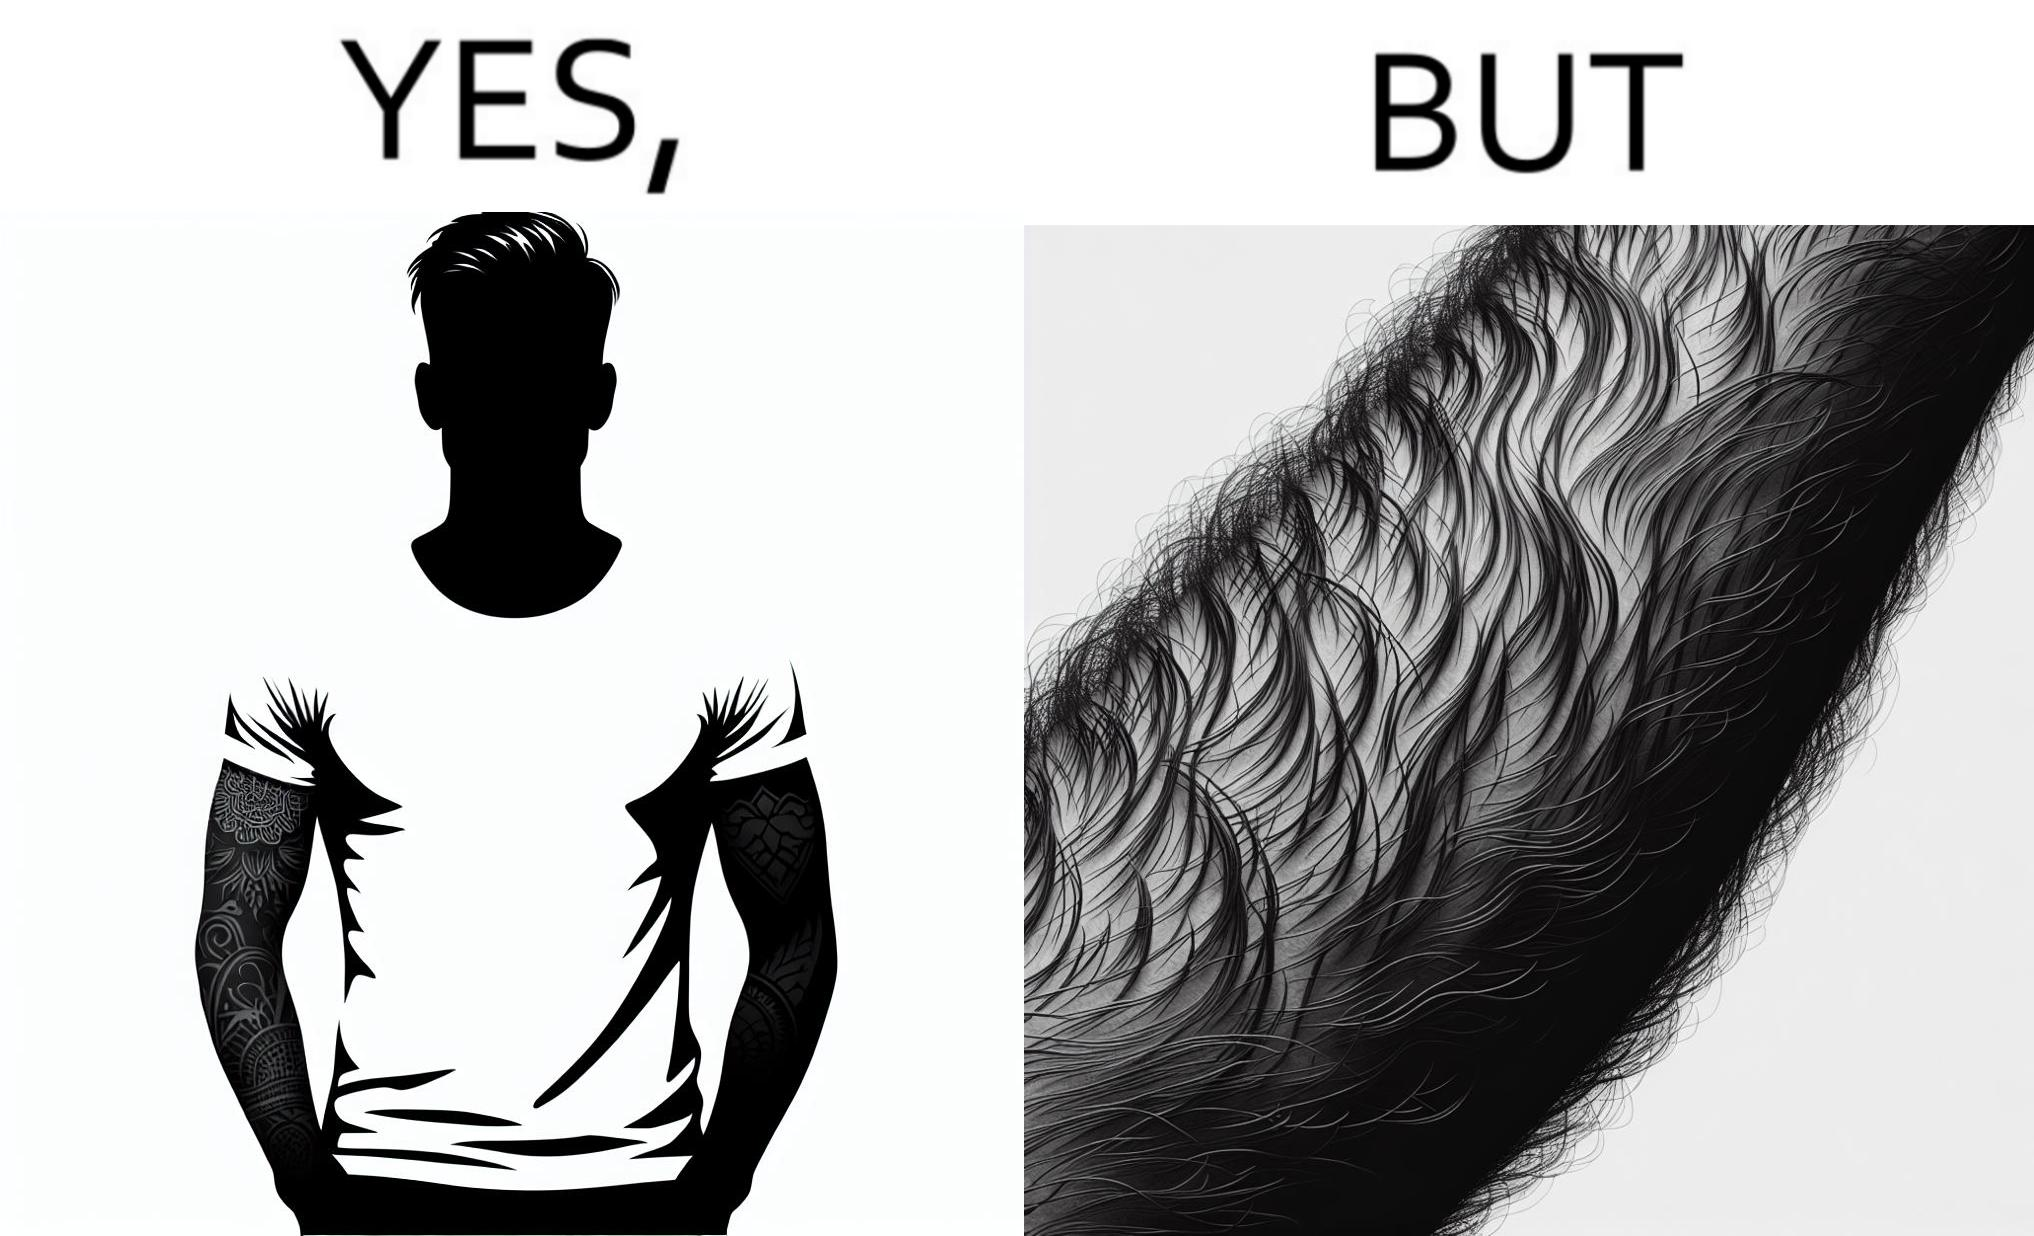Compare the left and right sides of this image. In the left part of the image: The image shows a man with tattoos on both of his arms. He is wearing white T-shirt . In the right part of the image: The image shows a closeup of an arm. The arm is shown to be very hairy and the hairs are wavy. 